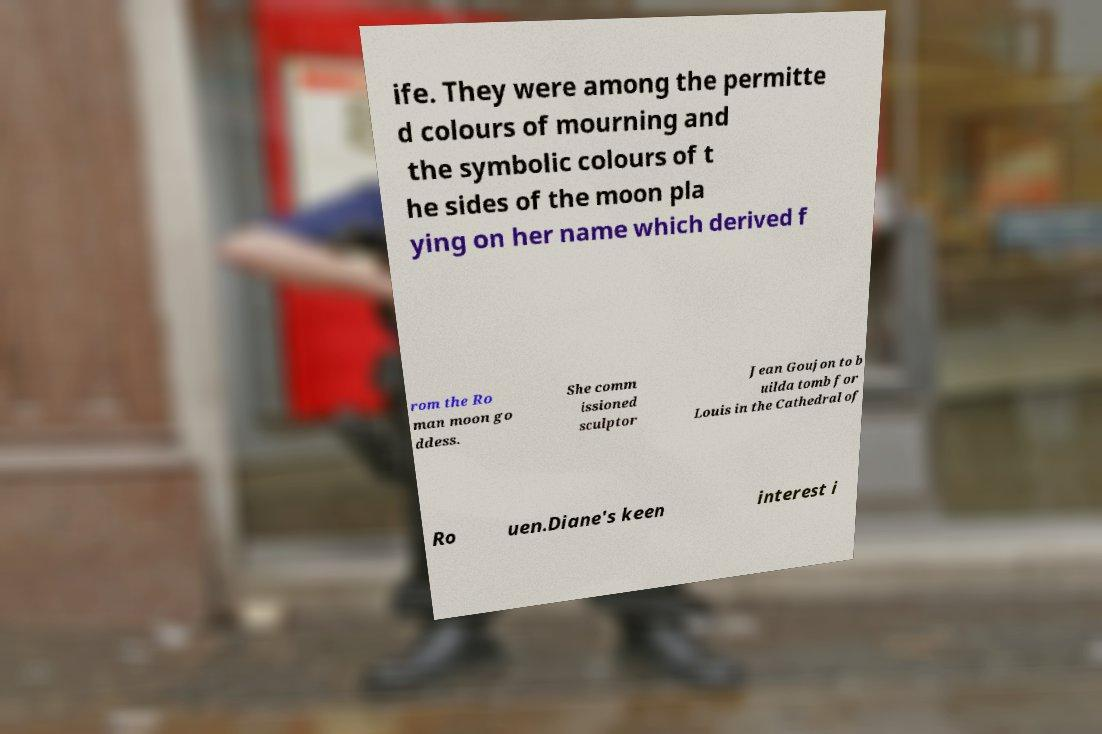There's text embedded in this image that I need extracted. Can you transcribe it verbatim? ife. They were among the permitte d colours of mourning and the symbolic colours of t he sides of the moon pla ying on her name which derived f rom the Ro man moon go ddess. She comm issioned sculptor Jean Goujon to b uilda tomb for Louis in the Cathedral of Ro uen.Diane's keen interest i 